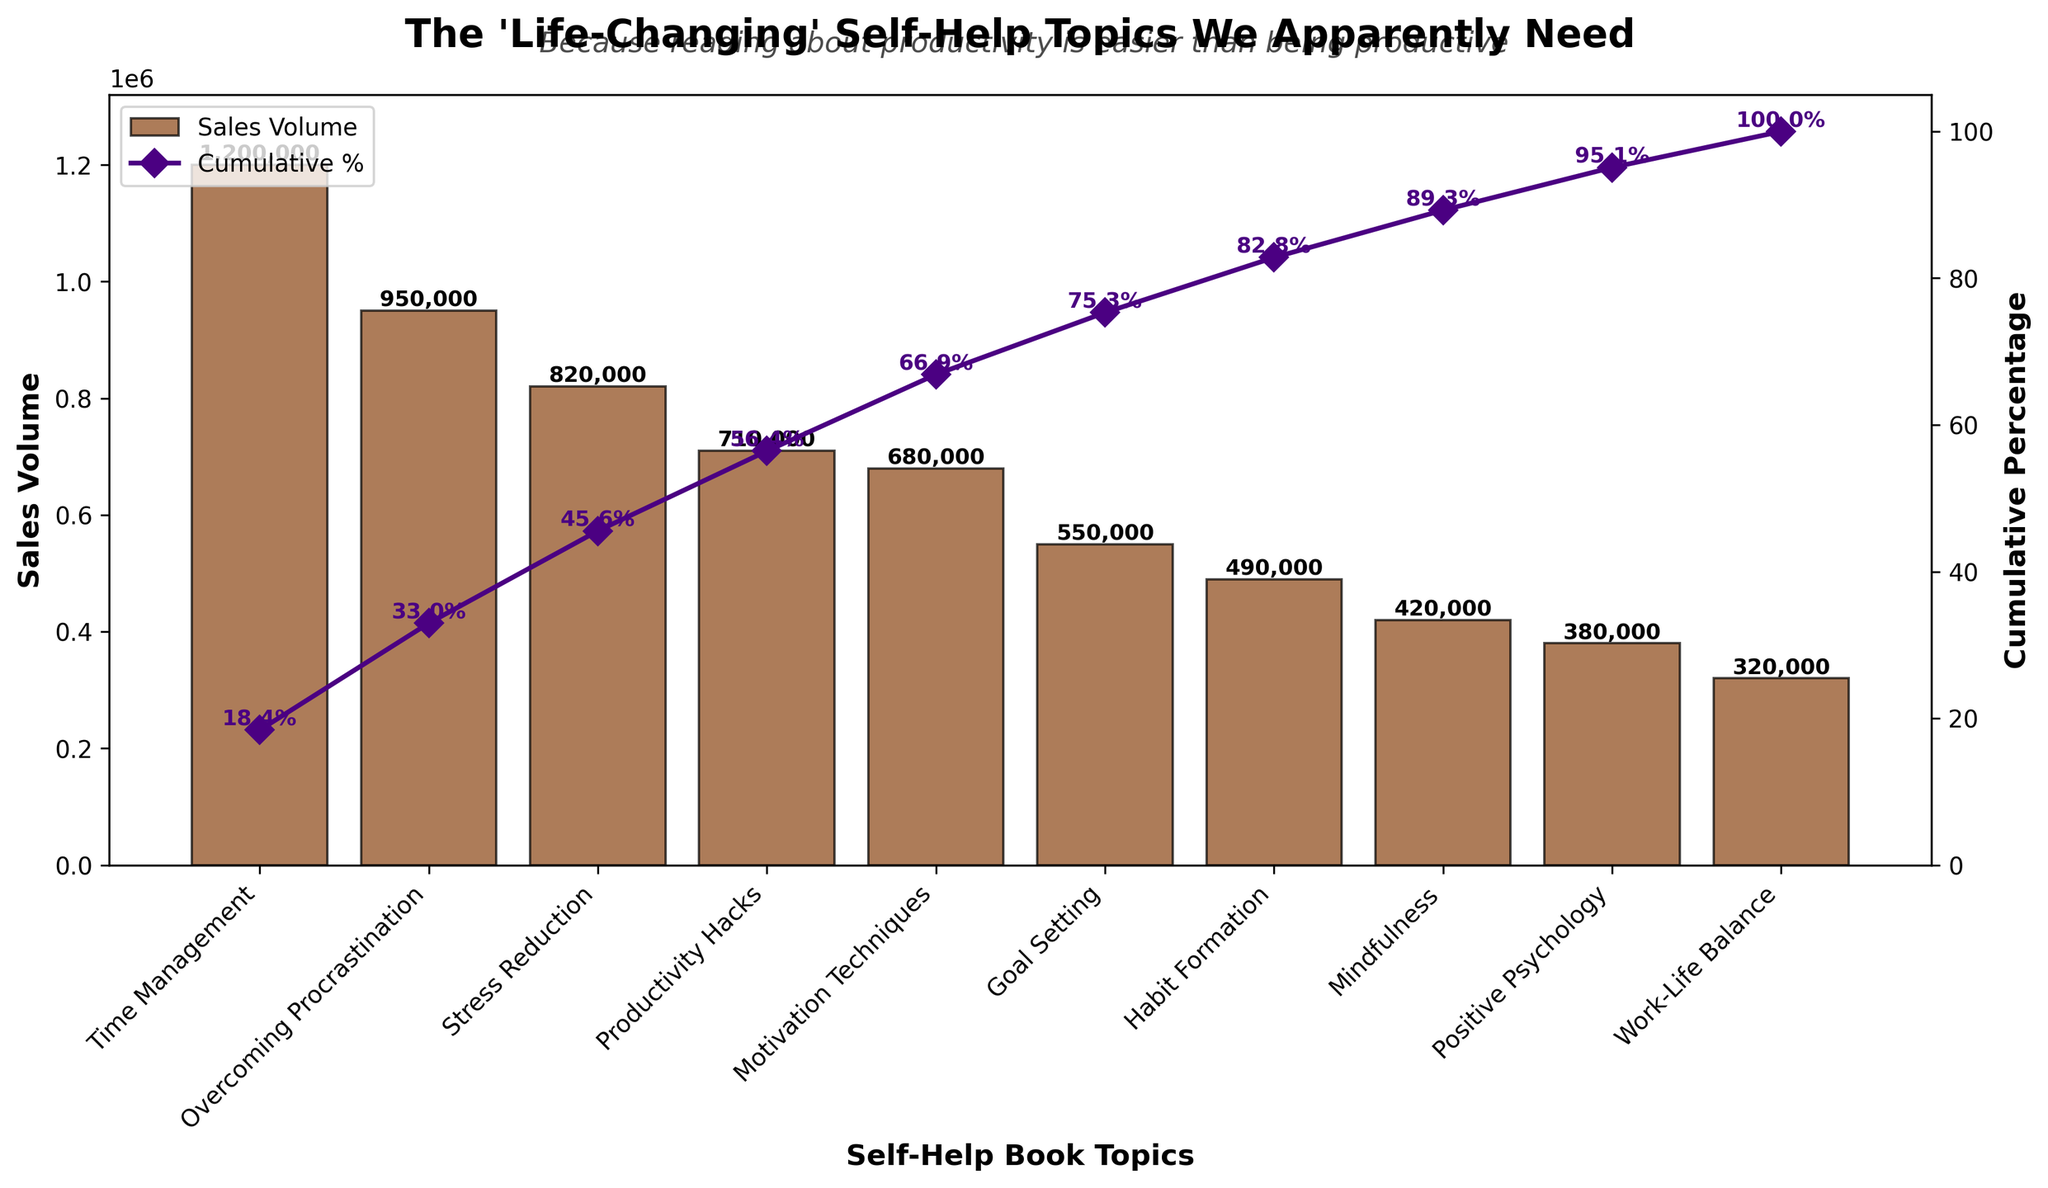What is the title of the figure? The title is located at the top of the figure. The title reads "The 'Life-Changing' Self-Help Topics We Apparently Need".
Answer: The 'Life-Changing' Self-Help Topics We Apparently Need Which topic has the highest sales volume? By looking at the highest bar in the bar chart, we can see that "Time Management" has the highest sales volume.
Answer: Time Management How many of the topics have sales volumes below 500,000? Identify the bars that represent sales volumes and count those below 500,000. The topics are Habit Formation, Mindfulness, Positive Psychology, and Work-Life Balance, which makes it 4 topics.
Answer: 4 What is the cumulative percentage for Motivation Techniques? Find the bar for "Motivation Techniques" and then check the cumulative percentage line corresponding to it. The cumulative percentage value is labeled as 76.7% above the marker on the line.
Answer: 76.7% Which topics contribute to at least 50% of the total sales volume? To find this, look at the cumulative percentage line until it crosses 50%. The topics contributing are Time Management, Overcoming Procrastination, and part of Stress Reduction.
Answer: Time Management, Overcoming Procrastination, Stress Reduction What is the sales volume difference between Time Management and Work-Life Balance? Find the bar heights representing the sales volumes for Time Management (1,200,000) and Work-Life Balance (320,000), then subtract the smaller value from the larger value. The difference is 1,200,000 - 320,000 = 880,000.
Answer: 880,000 What percentage of the total sales volume is attributed to the top three topics? Calculate the sales volumes for the top three topics: Time Management (1,200,000), Overcoming Procrastination (950,000), and Stress Reduction (820,000). Sum these volumes and divide by the total sales to get the percentage: (1,200,000 + 950,000 + 820,000) / 6,420,000 * 100 ≈ 46.6%.
Answer: 46.6% Which topic has the lowest sales volume, and what is that volume? The shortest bar in the bar chart represents the smallest sales volume. The topic is "Work-Life Balance" with a sales volume of 320,000.
Answer: Work-Life Balance, 320,000 How many topics have a cumulative percentage below 90%? Check the cumulative percentage line and count how many topics fall below the 90% marker. These are Time Management, Overcoming Procrastination, Stress Reduction, Productivity Hacks, and Motivation Techniques, totaling 5 topics.
Answer: 5 What is the total sales volume of all self-help book topics? The total sales volume is the sum of the sales volumes of each topic: 1,200,000 + 950,000 + 820,000 + 710,000 + 680,000 + 550,000 + 490,000 + 420,000 + 380,000 + 320,000 = 6,520,000. However, we use common totals provided to check cumulative percentages summing up to 6,420,000.
Answer: 6,420,000 